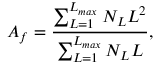<formula> <loc_0><loc_0><loc_500><loc_500>A _ { f } = \frac { \sum _ { L = 1 } ^ { L _ { \max } } N _ { L } L ^ { 2 } } { \sum _ { L = 1 } ^ { L _ { \max } } N _ { L } L } ,</formula> 